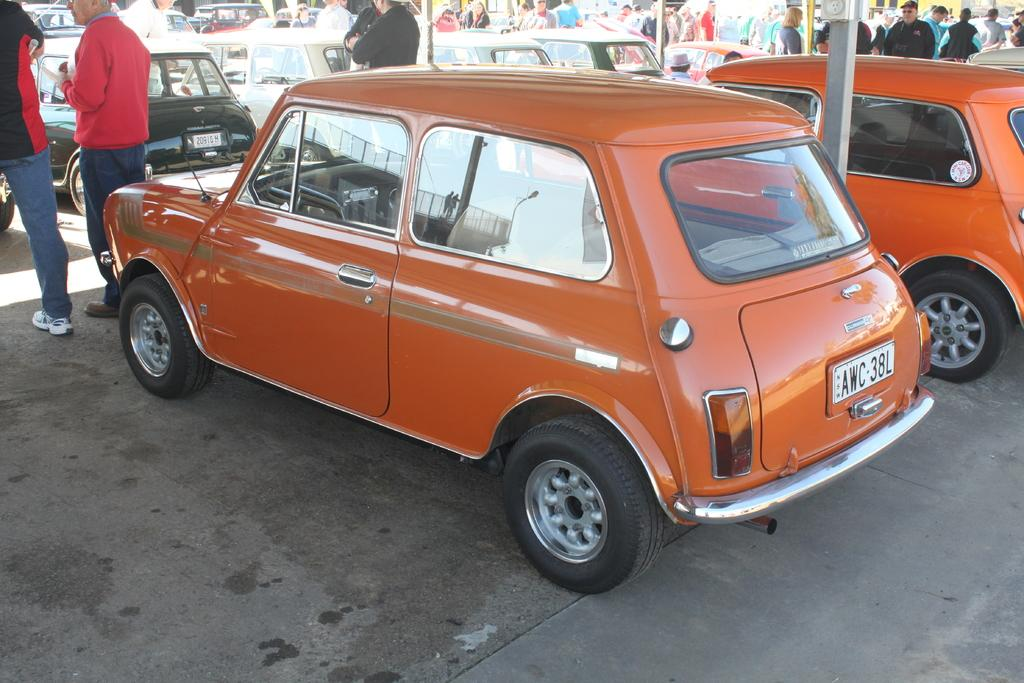What is in the foreground of the image? There are cars on the road in the foreground of the image. What else can be seen in the image besides the cars? There are poles visible in the image. Are there any people present in the image? Yes, there are people around the cars in the image. What type of competition is taking place between the beds in the image? There are no beds present in the image, so it is not possible to determine if a competition is taking place between them. 